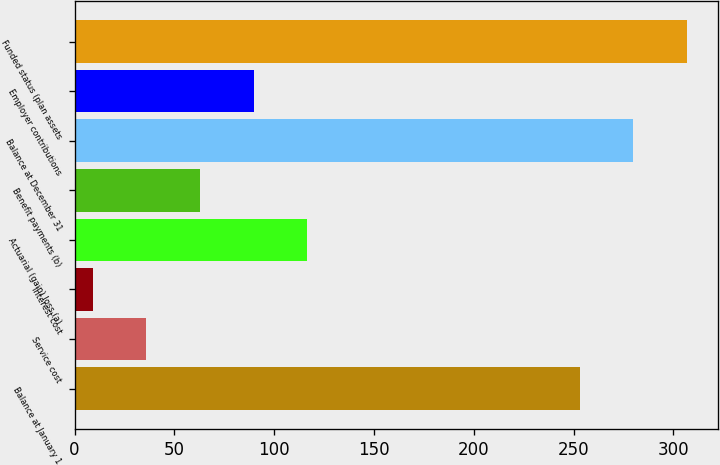Convert chart to OTSL. <chart><loc_0><loc_0><loc_500><loc_500><bar_chart><fcel>Balance at January 1<fcel>Service cost<fcel>Interest cost<fcel>Actuarial (gain) loss (a)<fcel>Benefit payments (b)<fcel>Balance at December 31<fcel>Employer contributions<fcel>Funded status (plan assets<nl><fcel>253<fcel>35.9<fcel>9<fcel>116.6<fcel>62.8<fcel>279.9<fcel>89.7<fcel>306.8<nl></chart> 